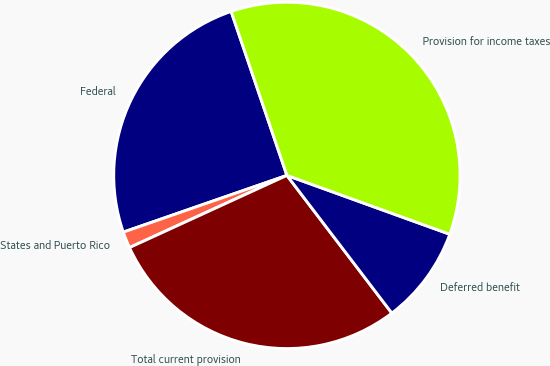<chart> <loc_0><loc_0><loc_500><loc_500><pie_chart><fcel>Federal<fcel>States and Puerto Rico<fcel>Total current provision<fcel>Deferred benefit<fcel>Provision for income taxes<nl><fcel>25.1%<fcel>1.53%<fcel>28.52%<fcel>9.12%<fcel>35.74%<nl></chart> 